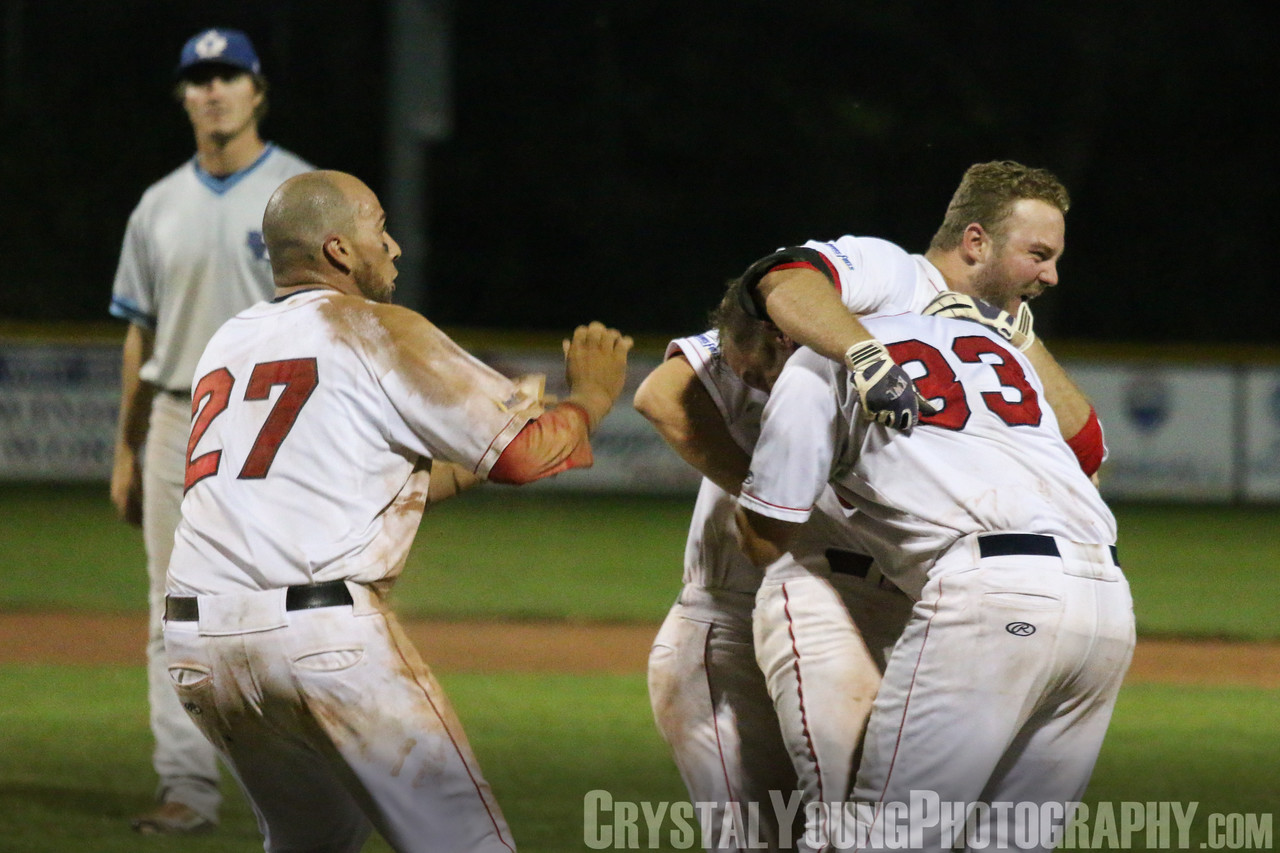If you were to write a caption for this image that captured its essence in one sentence, what would it be? "A moment of sheer elation and shared triumph as the winning run ignites the joyous celebration of a hard-fought victory, contrasted against the quiet resignation of defeat in the background." 